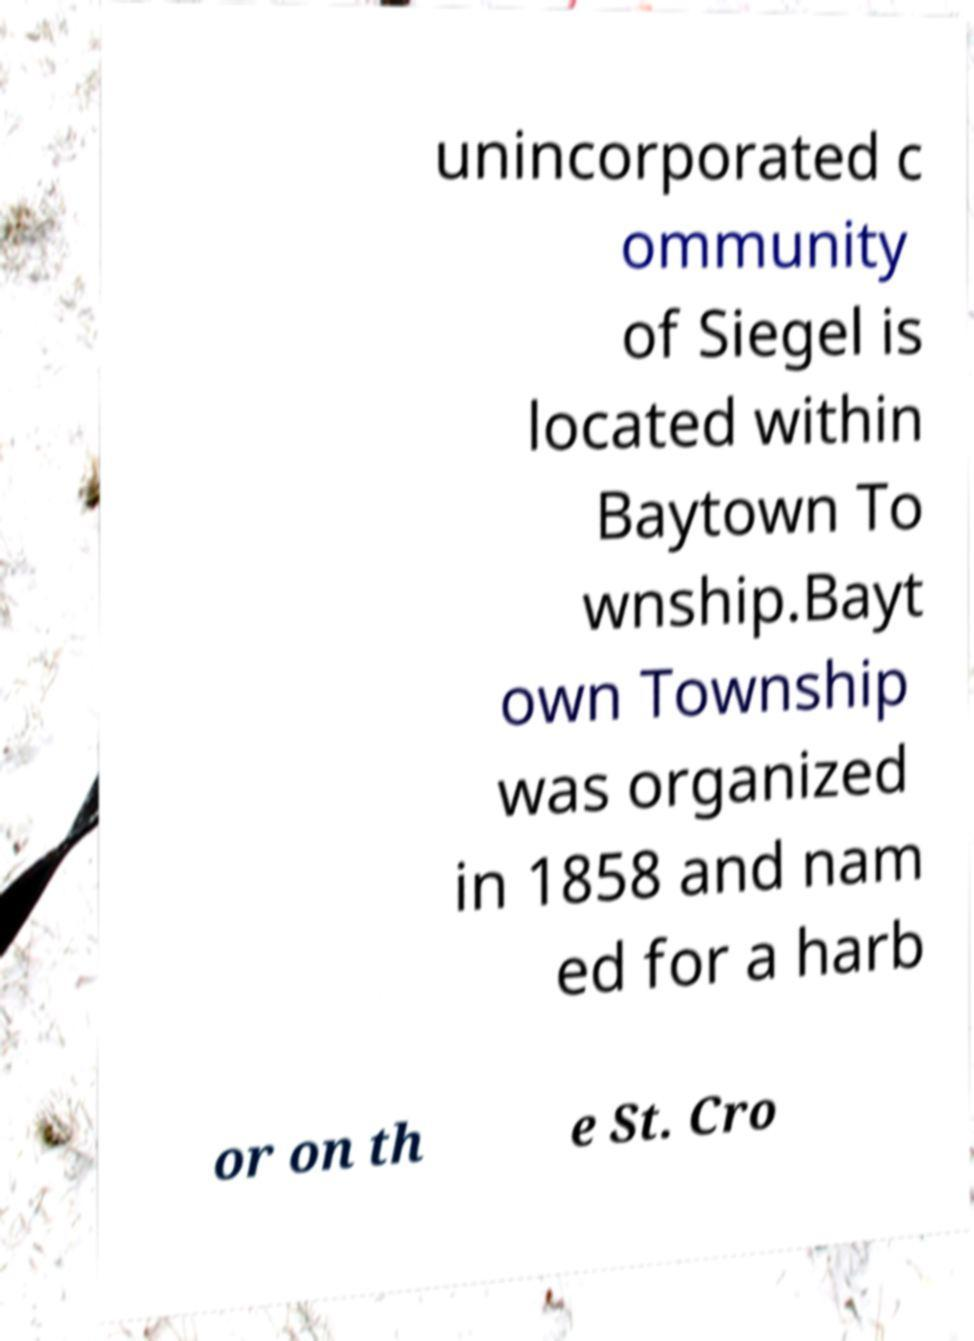Please read and relay the text visible in this image. What does it say? unincorporated c ommunity of Siegel is located within Baytown To wnship.Bayt own Township was organized in 1858 and nam ed for a harb or on th e St. Cro 